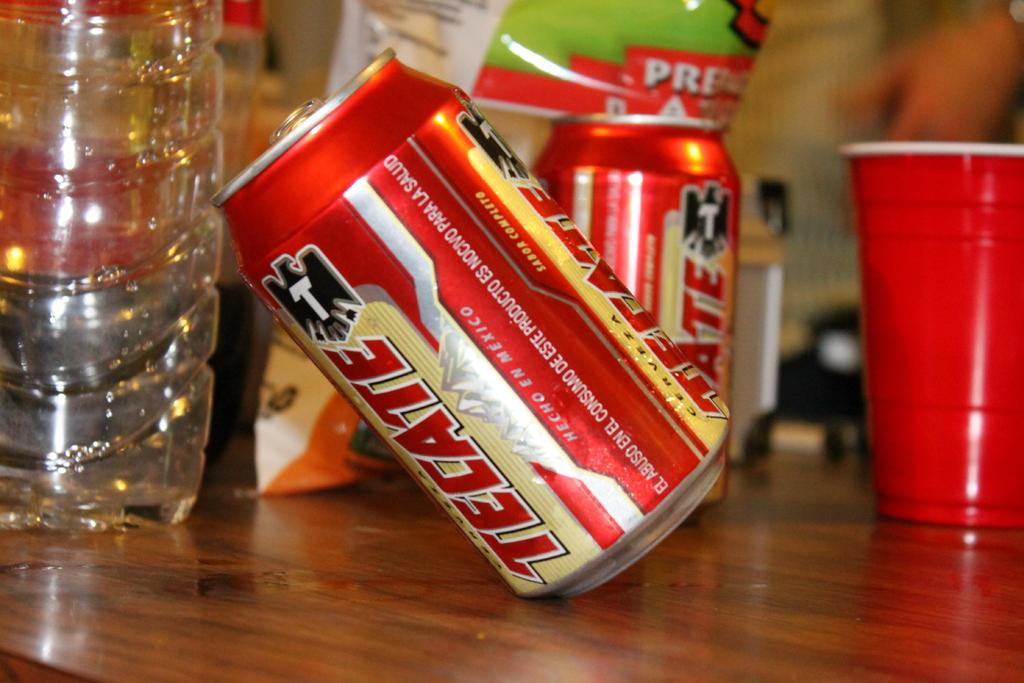<image>
Relay a brief, clear account of the picture shown. Tecate brand on cans tilted against a empty bottle. 